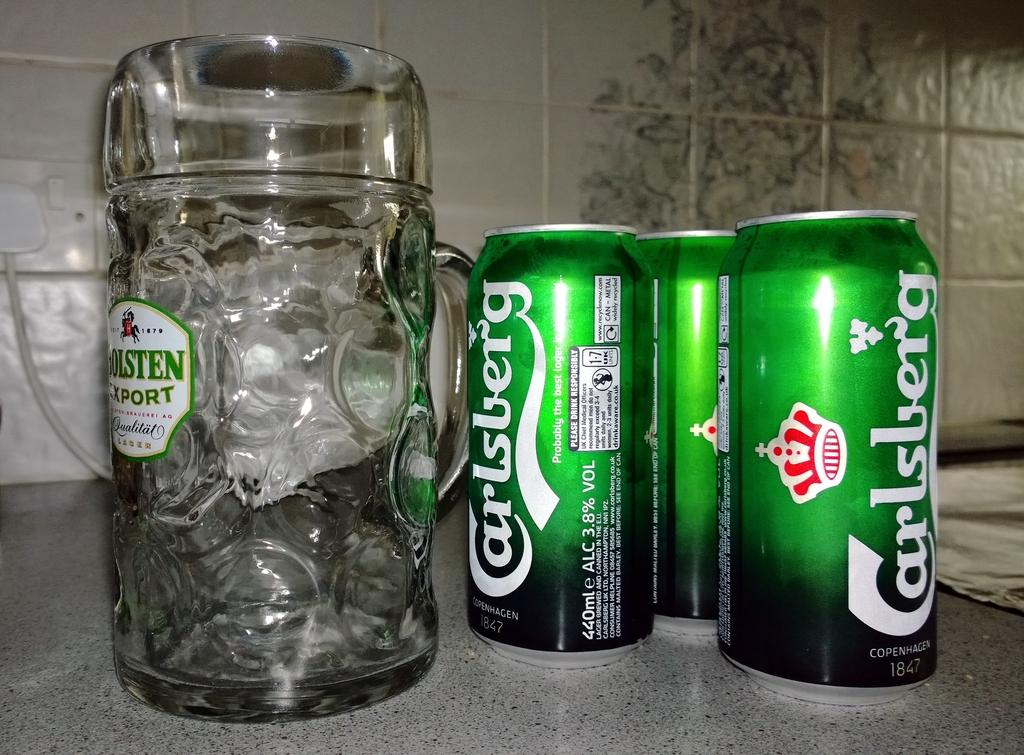<image>
Provide a brief description of the given image. Three cans of Carlsberg beer are on a counter, to the right of a Golsten, glass, beer mug. 